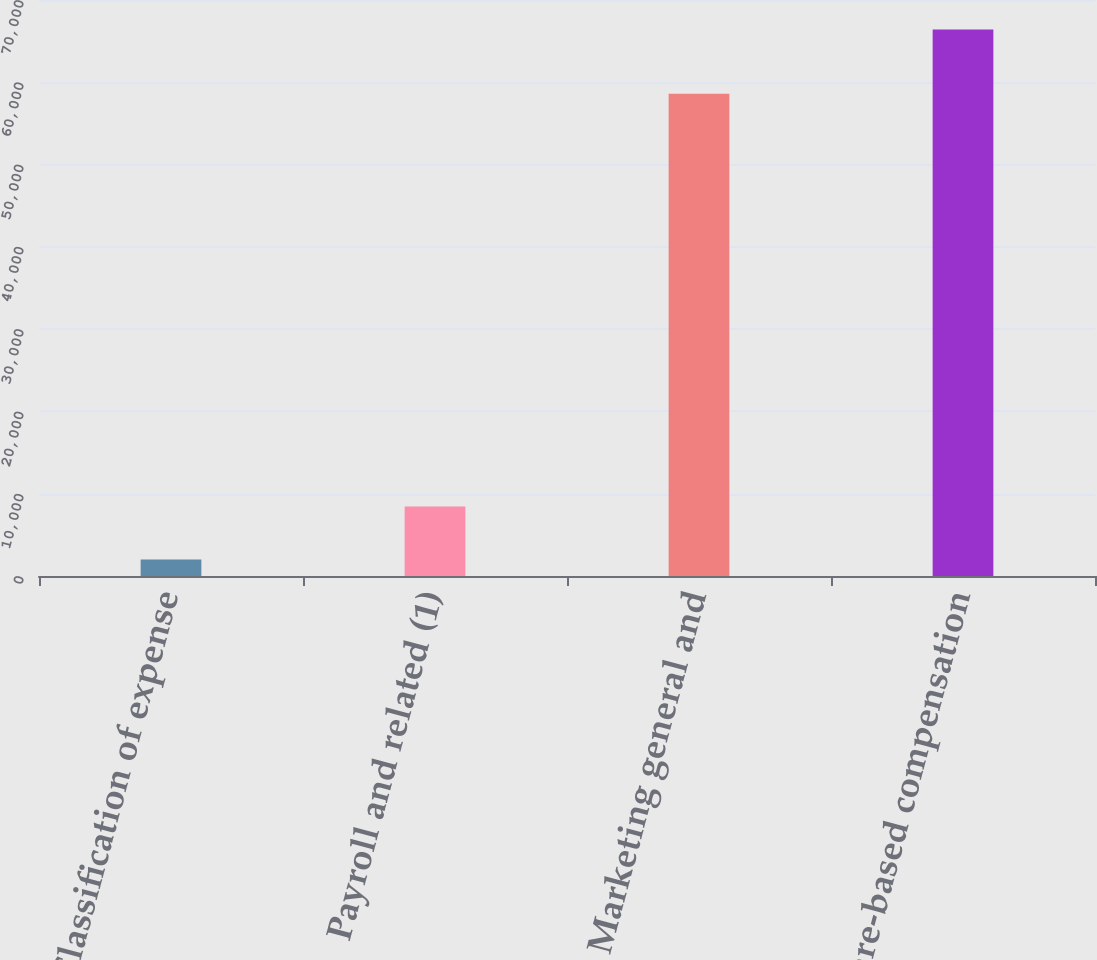<chart> <loc_0><loc_0><loc_500><loc_500><bar_chart><fcel>Classification of expense<fcel>Payroll and related (1)<fcel>Marketing general and<fcel>Total share-based compensation<nl><fcel>2016<fcel>8455.8<fcel>58621<fcel>66414<nl></chart> 